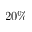Convert formula to latex. <formula><loc_0><loc_0><loc_500><loc_500>2 0 \%</formula> 